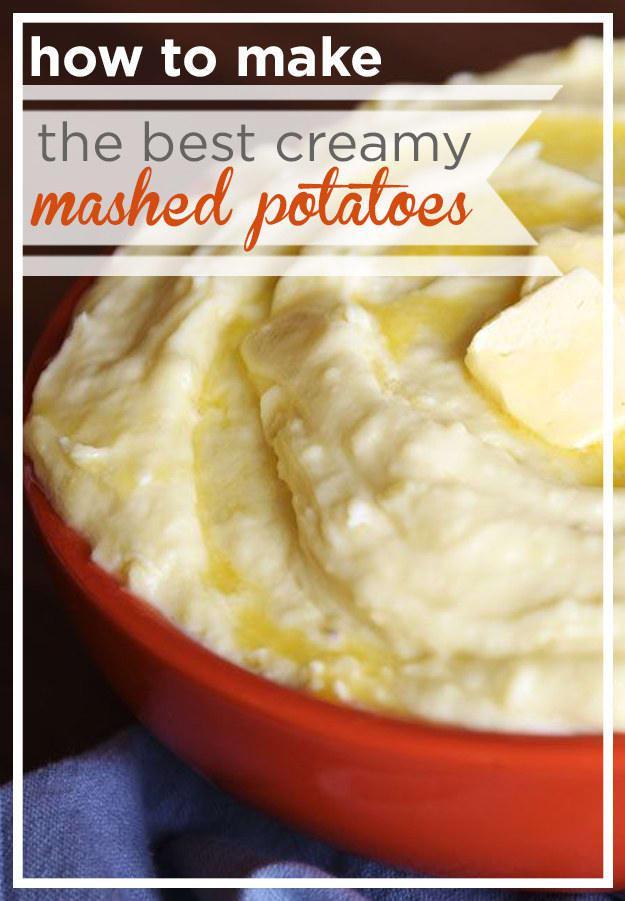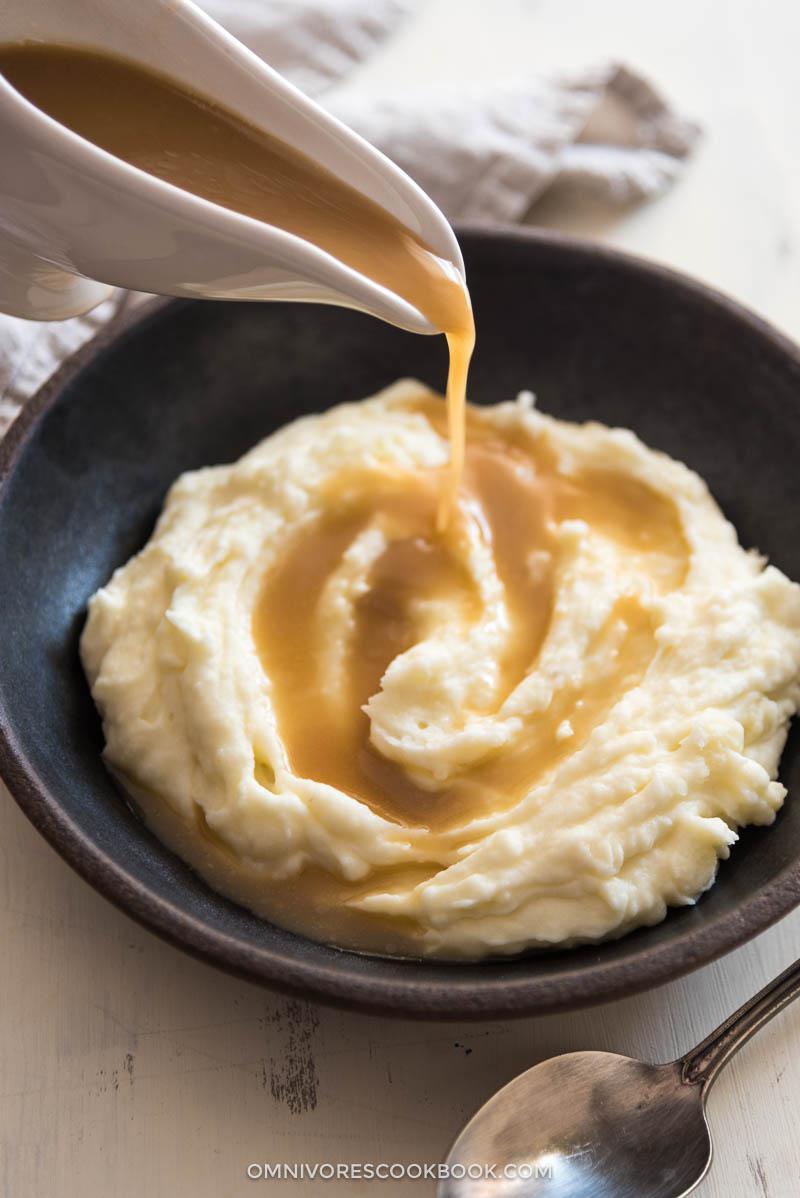The first image is the image on the left, the second image is the image on the right. Evaluate the accuracy of this statement regarding the images: "Left image shows a silver spoon next to a bowl of mashed potatoes.". Is it true? Answer yes or no. No. The first image is the image on the left, the second image is the image on the right. For the images shown, is this caption "There is a silver spoon near the bowl of food in the image on the left." true? Answer yes or no. No. 